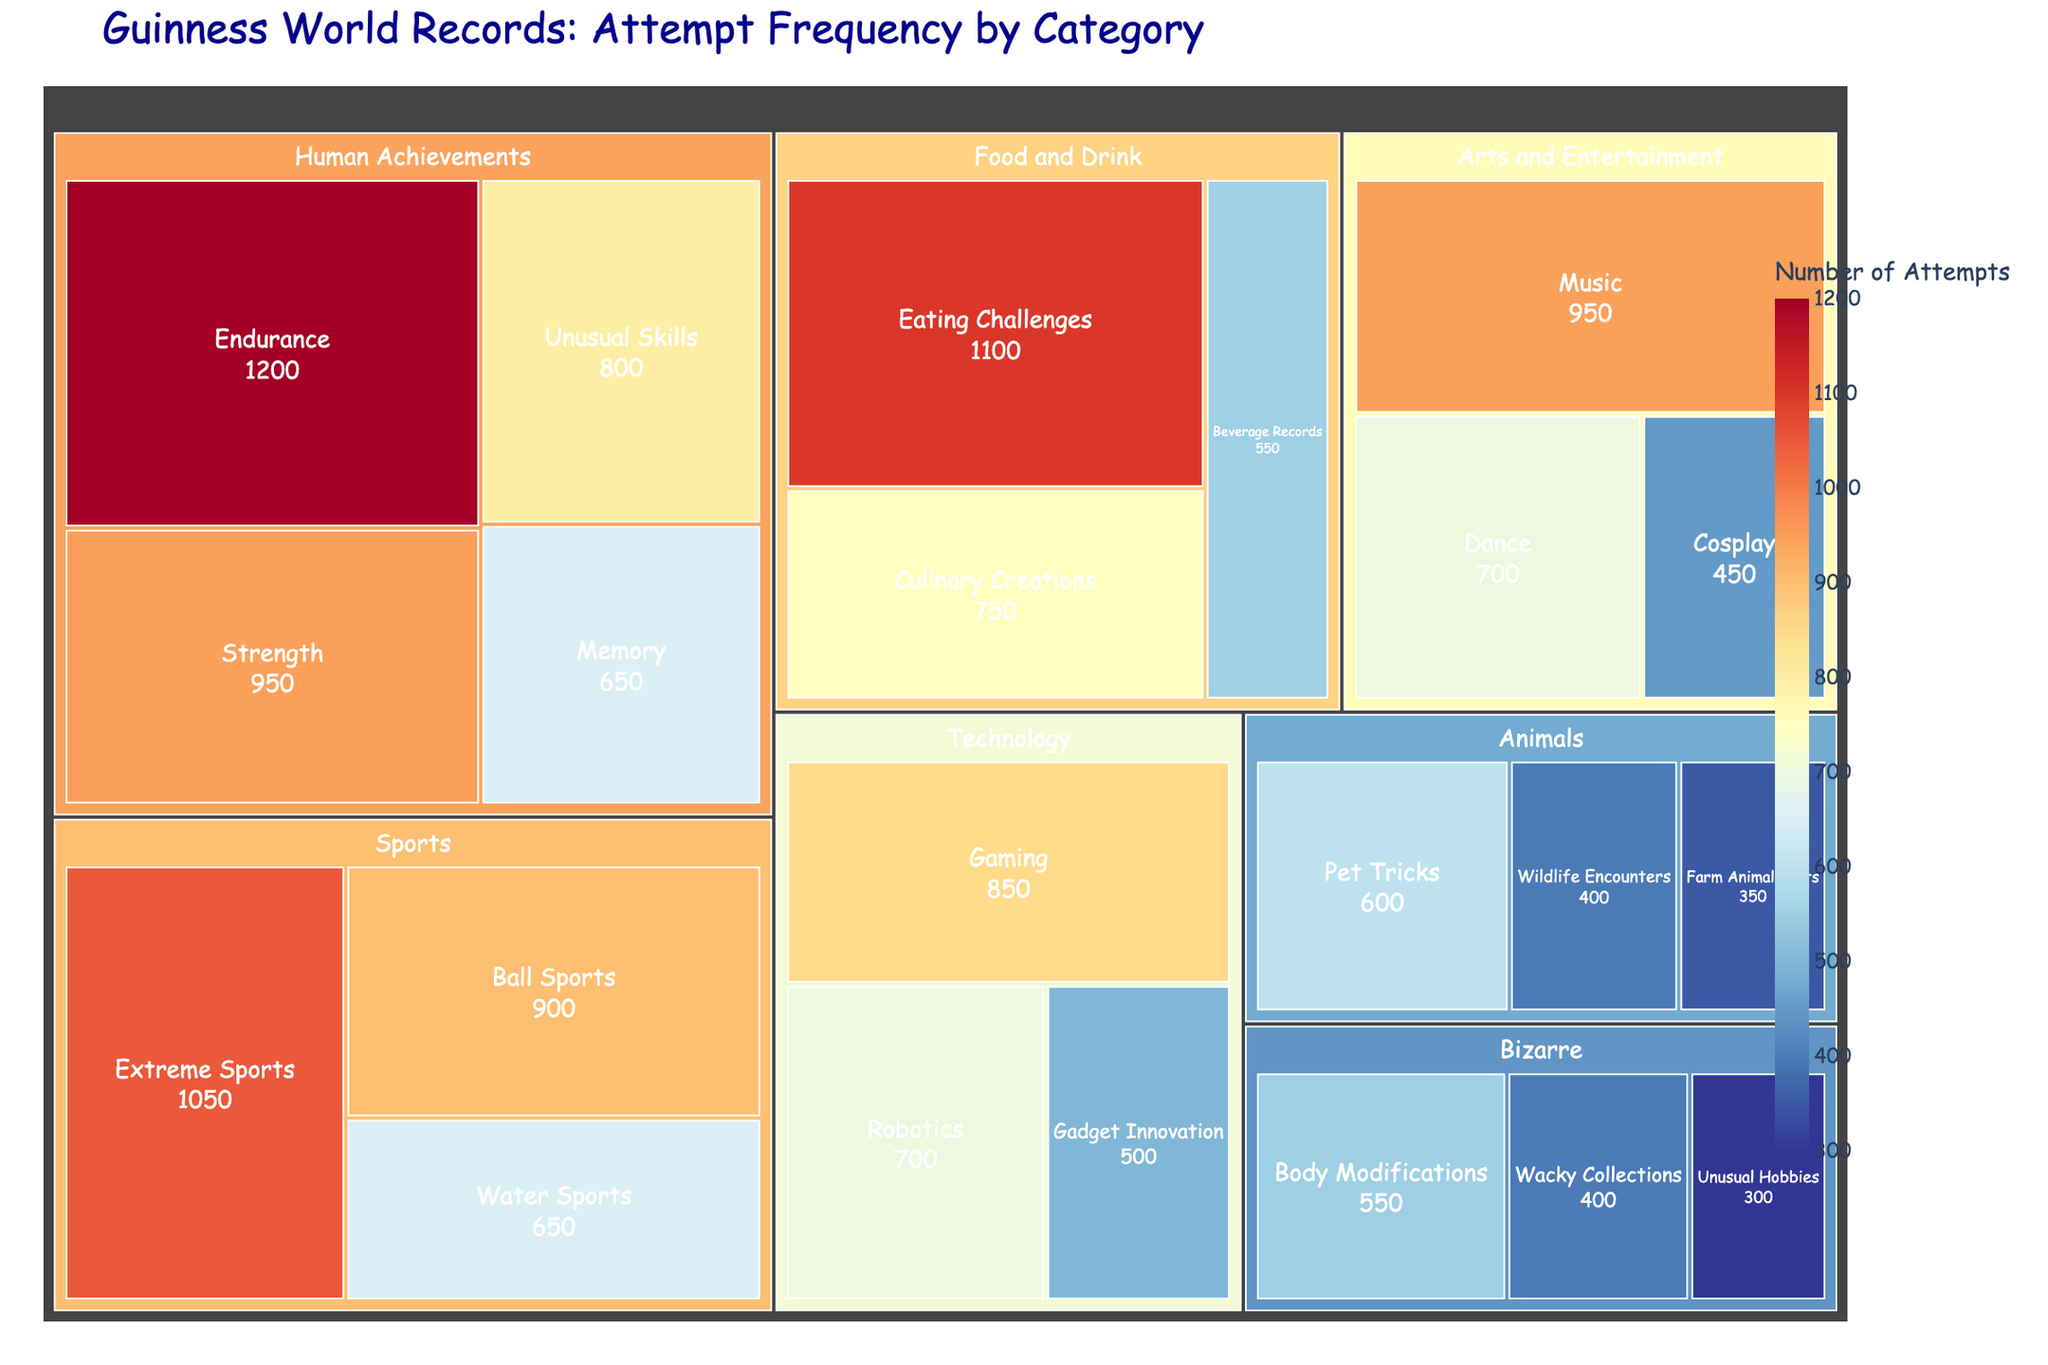What's the title of the figure? The title is displayed at the top of the treemap, often in a larger and bold font to highlight it as the main heading of the visualization. It reads "Guinness World Records: Attempt Frequency by Category".
Answer: Guinness World Records: Attempt Frequency by Category Which subcategory in the Food and Drink category has the highest number of attempts? Within the Food and Drink category, the subcategory with the highest number of attempts is displayed as the largest box under that category.
Answer: Eating Challenges How many attempts are there in the Bizarre category? To find the total number of attempts in the Bizarre category, sum the values of all the subcategories under Bizarre: Body Modifications (550), Wacky Collections (400), and Unusual Hobbies (300). So, 550 + 400 + 300 = 1250.
Answer: 1250 Which category has the least number of attempts in total? Sum the attempts in each category and compare them. The category with the smallest sum will have the least number of attempts. Summing attempts for each category, "Animals" has the lowest total with only 1350 attempts (Pet Tricks 600, Wildlife Encounters 400, Farm Animal Feats 350).
Answer: Animals What is the average number of attempts in the Technology category? Add up the attempts in the Technology category (Robotics 700, Gaming 850, Gadget Innovation 500) to get a total of 2050. Then, divide by the number of subcategories (3). So, 2050 / 3 = 683.33.
Answer: 683.33 Which subcategory in the Human Achievements category has fewer attempts than the average for their category? Calculate the average attempts for the Human Achievements category: (Endurance 1200 + Strength 950 + Memory 650 + Unusual Skills 800) / 4 = 900. Compare each subcategory against this average; Memory (650) and Unusual Skills (800) are below 900.
Answer: Memory, Unusual Skills In which subcategory do the number of attempts exceed 1000? Look for subcategories with over 1000 attempts: Endurance (1200 in Human Achievements), Eating Challenges (1100 in Food and Drink), Extreme Sports (1050 in Sports).
Answer: Endurance, Eating Challenges, Extreme Sports Is the number of attempts in Ball Sports greater than Dance? Compare the values of attempts for Ball Sports (900 in Sports) and Dance (700 in Arts and Entertainment). Since 900 > 700, the answer is yes.
Answer: Yes What is the difference in the number of attempts between Pet Tricks and Gadget Innovation? Subtract the number of attempts in Gadget Innovation (500 in Technology) from Pet Tricks (600 in Animals). So, 600 - 500 = 100.
Answer: 100 Which subcategory has the least number of attempts overall, and how many attempts does it have? Identify the subcategory with the smallest box in the treemap, which represents Unusual Hobbies with 300 attempts in the Bizarre category.
Answer: Unusual Hobbies, 300 